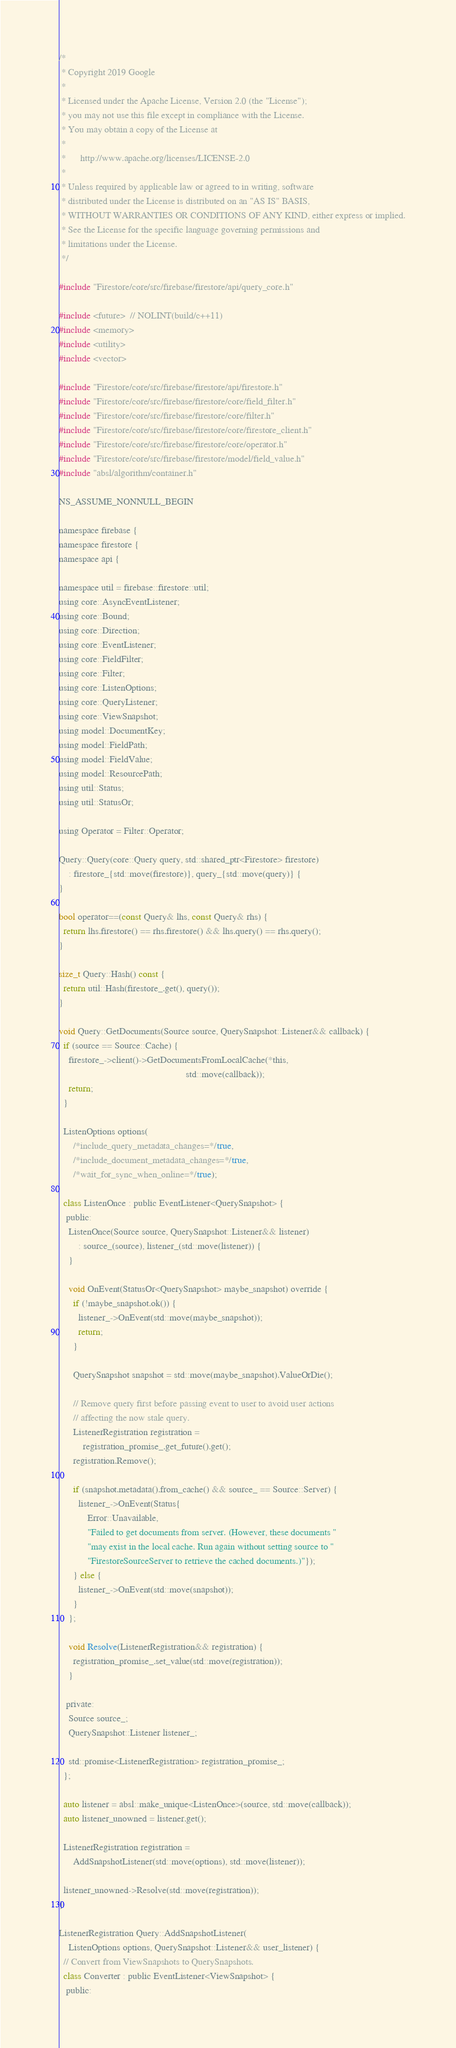<code> <loc_0><loc_0><loc_500><loc_500><_ObjectiveC_>/*
 * Copyright 2019 Google
 *
 * Licensed under the Apache License, Version 2.0 (the "License");
 * you may not use this file except in compliance with the License.
 * You may obtain a copy of the License at
 *
 *      http://www.apache.org/licenses/LICENSE-2.0
 *
 * Unless required by applicable law or agreed to in writing, software
 * distributed under the License is distributed on an "AS IS" BASIS,
 * WITHOUT WARRANTIES OR CONDITIONS OF ANY KIND, either express or implied.
 * See the License for the specific language governing permissions and
 * limitations under the License.
 */

#include "Firestore/core/src/firebase/firestore/api/query_core.h"

#include <future>  // NOLINT(build/c++11)
#include <memory>
#include <utility>
#include <vector>

#include "Firestore/core/src/firebase/firestore/api/firestore.h"
#include "Firestore/core/src/firebase/firestore/core/field_filter.h"
#include "Firestore/core/src/firebase/firestore/core/filter.h"
#include "Firestore/core/src/firebase/firestore/core/firestore_client.h"
#include "Firestore/core/src/firebase/firestore/core/operator.h"
#include "Firestore/core/src/firebase/firestore/model/field_value.h"
#include "absl/algorithm/container.h"

NS_ASSUME_NONNULL_BEGIN

namespace firebase {
namespace firestore {
namespace api {

namespace util = firebase::firestore::util;
using core::AsyncEventListener;
using core::Bound;
using core::Direction;
using core::EventListener;
using core::FieldFilter;
using core::Filter;
using core::ListenOptions;
using core::QueryListener;
using core::ViewSnapshot;
using model::DocumentKey;
using model::FieldPath;
using model::FieldValue;
using model::ResourcePath;
using util::Status;
using util::StatusOr;

using Operator = Filter::Operator;

Query::Query(core::Query query, std::shared_ptr<Firestore> firestore)
    : firestore_{std::move(firestore)}, query_{std::move(query)} {
}

bool operator==(const Query& lhs, const Query& rhs) {
  return lhs.firestore() == rhs.firestore() && lhs.query() == rhs.query();
}

size_t Query::Hash() const {
  return util::Hash(firestore_.get(), query());
}

void Query::GetDocuments(Source source, QuerySnapshot::Listener&& callback) {
  if (source == Source::Cache) {
    firestore_->client()->GetDocumentsFromLocalCache(*this,
                                                     std::move(callback));
    return;
  }

  ListenOptions options(
      /*include_query_metadata_changes=*/true,
      /*include_document_metadata_changes=*/true,
      /*wait_for_sync_when_online=*/true);

  class ListenOnce : public EventListener<QuerySnapshot> {
   public:
    ListenOnce(Source source, QuerySnapshot::Listener&& listener)
        : source_(source), listener_(std::move(listener)) {
    }

    void OnEvent(StatusOr<QuerySnapshot> maybe_snapshot) override {
      if (!maybe_snapshot.ok()) {
        listener_->OnEvent(std::move(maybe_snapshot));
        return;
      }

      QuerySnapshot snapshot = std::move(maybe_snapshot).ValueOrDie();

      // Remove query first before passing event to user to avoid user actions
      // affecting the now stale query.
      ListenerRegistration registration =
          registration_promise_.get_future().get();
      registration.Remove();

      if (snapshot.metadata().from_cache() && source_ == Source::Server) {
        listener_->OnEvent(Status{
            Error::Unavailable,
            "Failed to get documents from server. (However, these documents "
            "may exist in the local cache. Run again without setting source to "
            "FirestoreSourceServer to retrieve the cached documents.)"});
      } else {
        listener_->OnEvent(std::move(snapshot));
      }
    };

    void Resolve(ListenerRegistration&& registration) {
      registration_promise_.set_value(std::move(registration));
    }

   private:
    Source source_;
    QuerySnapshot::Listener listener_;

    std::promise<ListenerRegistration> registration_promise_;
  };

  auto listener = absl::make_unique<ListenOnce>(source, std::move(callback));
  auto listener_unowned = listener.get();

  ListenerRegistration registration =
      AddSnapshotListener(std::move(options), std::move(listener));

  listener_unowned->Resolve(std::move(registration));
}

ListenerRegistration Query::AddSnapshotListener(
    ListenOptions options, QuerySnapshot::Listener&& user_listener) {
  // Convert from ViewSnapshots to QuerySnapshots.
  class Converter : public EventListener<ViewSnapshot> {
   public:</code> 